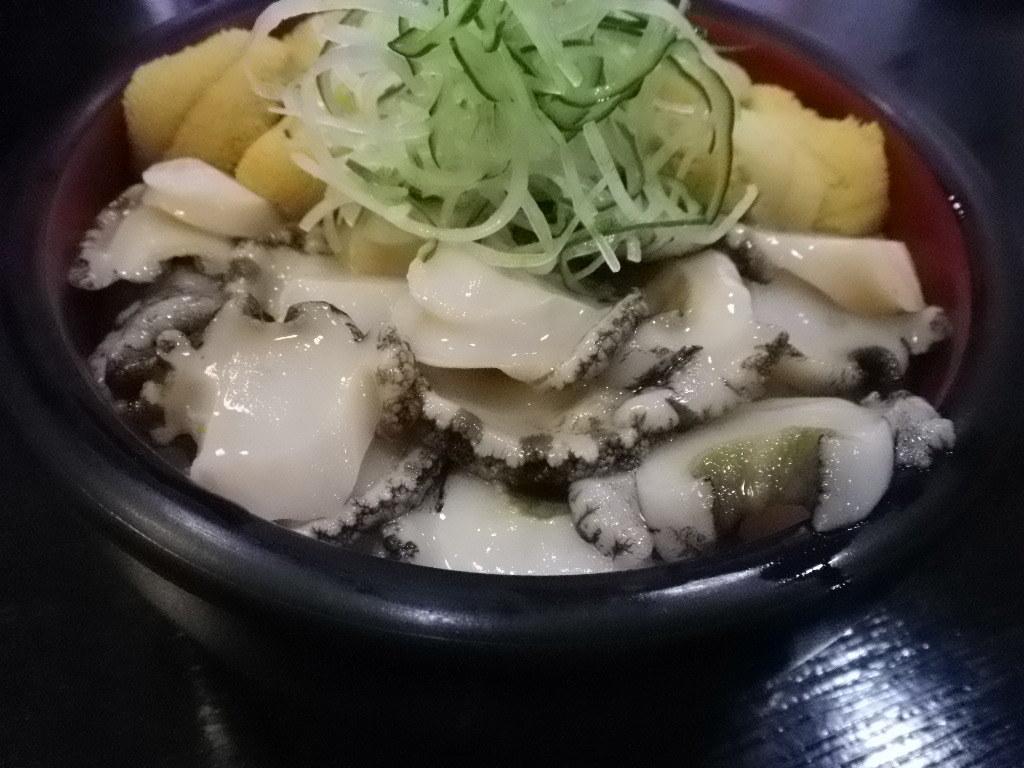Describe this image in one or two sentences. In this image I can see food item in a black color bowl. This bowl is on a wooden surface. 